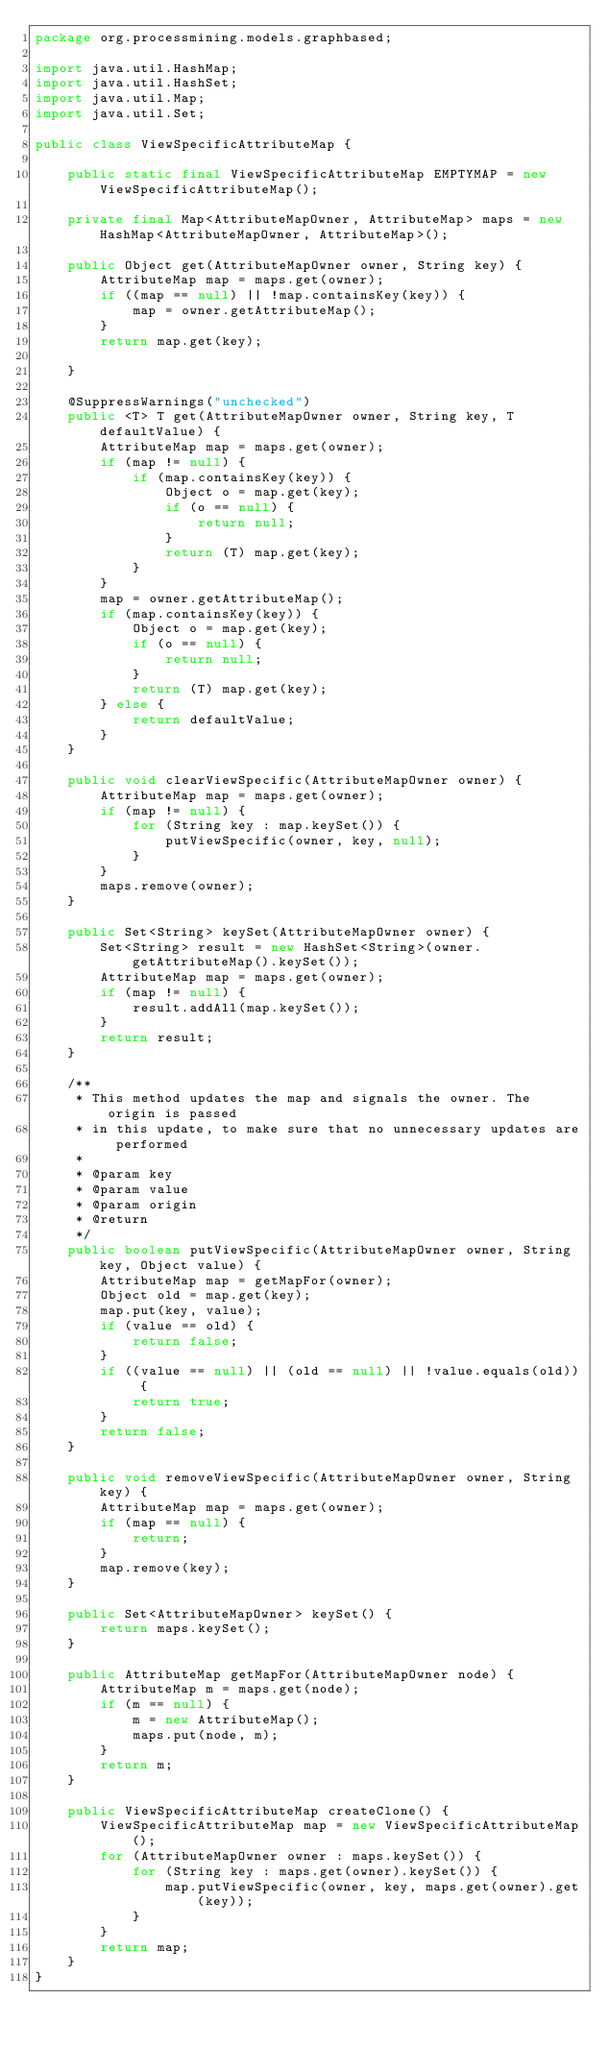<code> <loc_0><loc_0><loc_500><loc_500><_Java_>package org.processmining.models.graphbased;

import java.util.HashMap;
import java.util.HashSet;
import java.util.Map;
import java.util.Set;

public class ViewSpecificAttributeMap {

	public static final ViewSpecificAttributeMap EMPTYMAP = new ViewSpecificAttributeMap();

	private final Map<AttributeMapOwner, AttributeMap> maps = new HashMap<AttributeMapOwner, AttributeMap>();

	public Object get(AttributeMapOwner owner, String key) {
		AttributeMap map = maps.get(owner);
		if ((map == null) || !map.containsKey(key)) {
			map = owner.getAttributeMap();
		}
		return map.get(key);

	}

	@SuppressWarnings("unchecked")
	public <T> T get(AttributeMapOwner owner, String key, T defaultValue) {
		AttributeMap map = maps.get(owner);
		if (map != null) {
			if (map.containsKey(key)) {
				Object o = map.get(key);
				if (o == null) {
					return null;
				}
				return (T) map.get(key);
			}
		}
		map = owner.getAttributeMap();
		if (map.containsKey(key)) {
			Object o = map.get(key);
			if (o == null) {
				return null;
			}
			return (T) map.get(key);
		} else {
			return defaultValue;
		}
	}

	public void clearViewSpecific(AttributeMapOwner owner) {
		AttributeMap map = maps.get(owner);
		if (map != null) {
			for (String key : map.keySet()) {
				putViewSpecific(owner, key, null);
			}
		}
		maps.remove(owner);
	}

	public Set<String> keySet(AttributeMapOwner owner) {
		Set<String> result = new HashSet<String>(owner.getAttributeMap().keySet());
		AttributeMap map = maps.get(owner);
		if (map != null) {
			result.addAll(map.keySet());
		}
		return result;
	}

	/**
	 * This method updates the map and signals the owner. The origin is passed
	 * in this update, to make sure that no unnecessary updates are performed
	 * 
	 * @param key
	 * @param value
	 * @param origin
	 * @return
	 */
	public boolean putViewSpecific(AttributeMapOwner owner, String key, Object value) {
		AttributeMap map = getMapFor(owner);
		Object old = map.get(key);
		map.put(key, value);
		if (value == old) {
			return false;
		}
		if ((value == null) || (old == null) || !value.equals(old)) {
			return true;
		}
		return false;
	}

	public void removeViewSpecific(AttributeMapOwner owner, String key) {
		AttributeMap map = maps.get(owner);
		if (map == null) {
			return;
		}
		map.remove(key);
	}

	public Set<AttributeMapOwner> keySet() {
		return maps.keySet();
	}

	public AttributeMap getMapFor(AttributeMapOwner node) {
		AttributeMap m = maps.get(node);
		if (m == null) {
			m = new AttributeMap();
			maps.put(node, m);
		}
		return m;
	}

	public ViewSpecificAttributeMap createClone() {
		ViewSpecificAttributeMap map = new ViewSpecificAttributeMap();
		for (AttributeMapOwner owner : maps.keySet()) {
			for (String key : maps.get(owner).keySet()) {
				map.putViewSpecific(owner, key, maps.get(owner).get(key));
			}
		}
		return map;
	}
}
</code> 